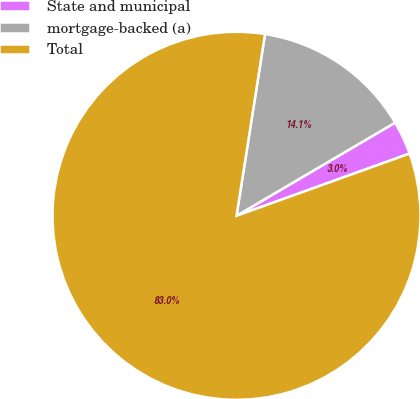Convert chart to OTSL. <chart><loc_0><loc_0><loc_500><loc_500><pie_chart><fcel>State and municipal<fcel>mortgage-backed (a)<fcel>Total<nl><fcel>2.96%<fcel>14.07%<fcel>82.97%<nl></chart> 